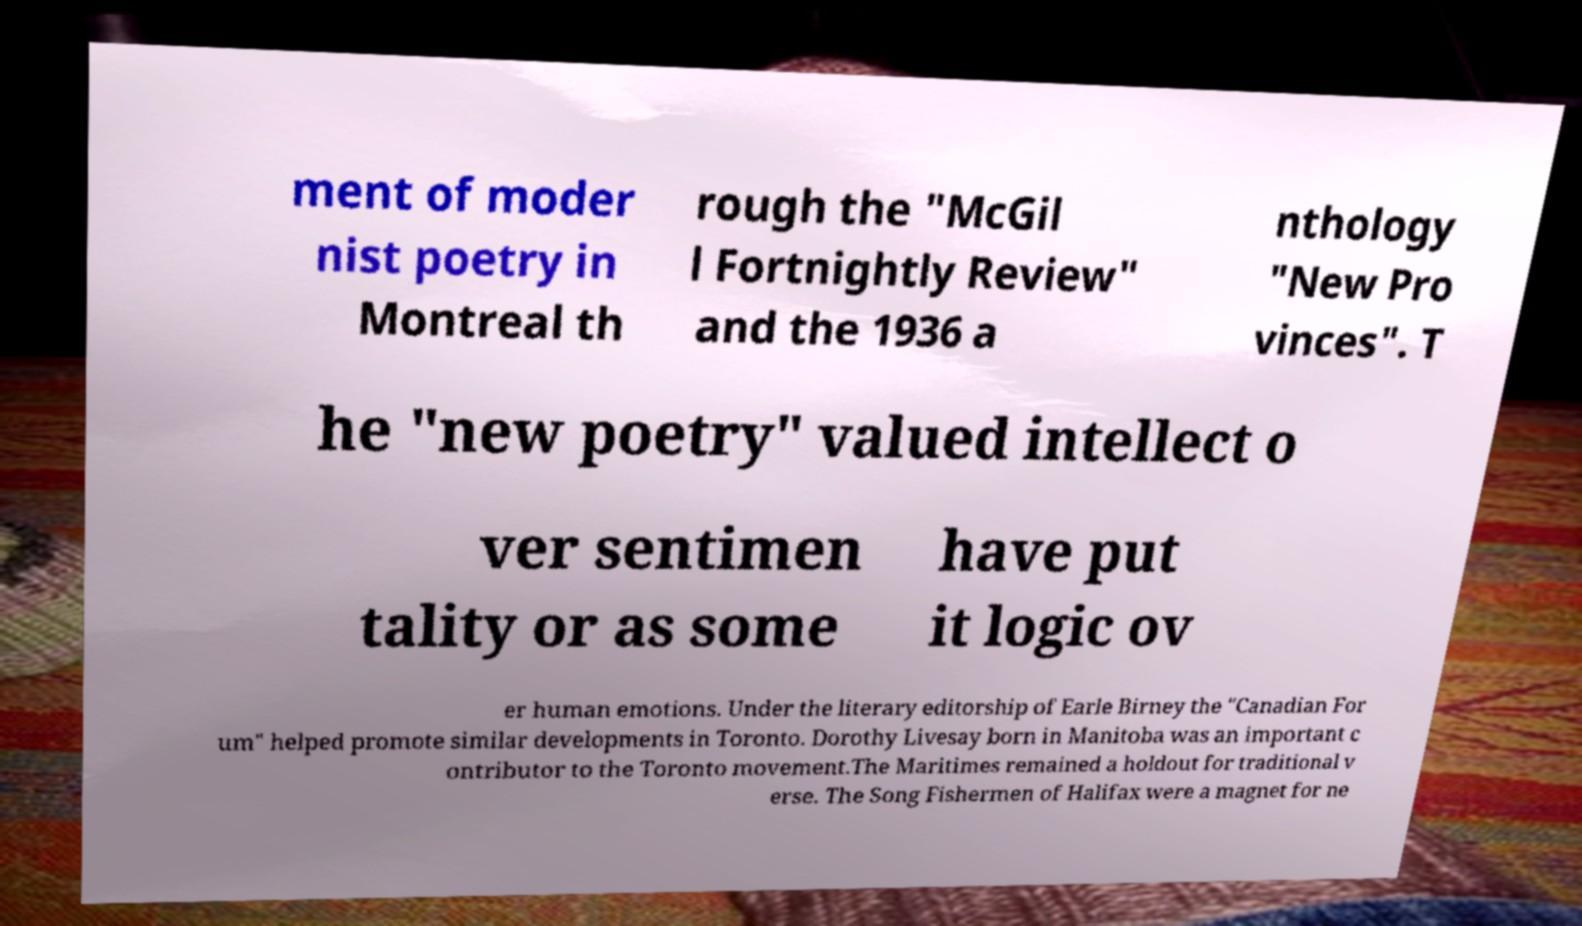Please read and relay the text visible in this image. What does it say? ment of moder nist poetry in Montreal th rough the "McGil l Fortnightly Review" and the 1936 a nthology "New Pro vinces". T he "new poetry" valued intellect o ver sentimen tality or as some have put it logic ov er human emotions. Under the literary editorship of Earle Birney the "Canadian For um" helped promote similar developments in Toronto. Dorothy Livesay born in Manitoba was an important c ontributor to the Toronto movement.The Maritimes remained a holdout for traditional v erse. The Song Fishermen of Halifax were a magnet for ne 